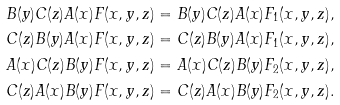<formula> <loc_0><loc_0><loc_500><loc_500>B ( y ) C ( z ) A ( x ) F ( x , y , z ) & = B ( y ) C ( z ) A ( x ) F _ { 1 } ( x , y , z ) , \\ C ( z ) B ( y ) A ( x ) F ( x , y , z ) & = C ( z ) B ( y ) A ( x ) F _ { 1 } ( x , y , z ) , \\ A ( x ) C ( z ) B ( y ) F ( x , y , z ) & = A ( x ) C ( z ) B ( y ) F _ { 2 } ( x , y , z ) , \\ C ( z ) A ( x ) B ( y ) F ( x , y , z ) & = C ( z ) A ( x ) B ( y ) F _ { 2 } ( x , y , z ) .</formula> 